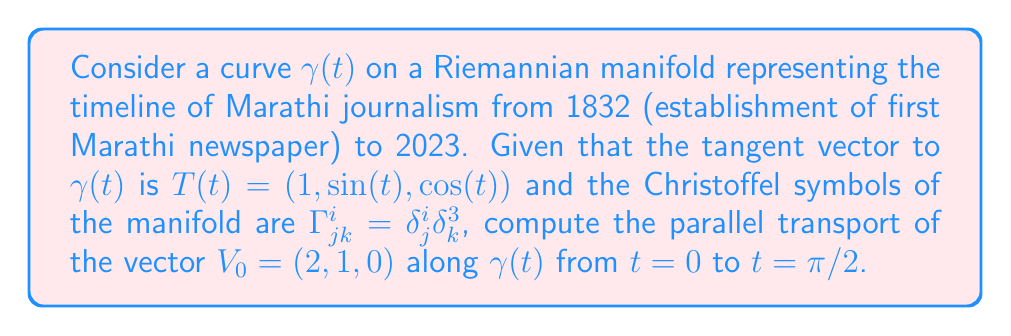Show me your answer to this math problem. To solve this problem, we'll follow these steps:

1) The parallel transport equation is given by:

   $$\frac{dV^i}{dt} + \Gamma^i_{jk} \frac{dx^j}{dt} V^k = 0$$

2) Given $\Gamma^i_{jk} = \delta^i_j \delta_k^3$, we can simplify this equation:

   $$\frac{dV^i}{dt} + \delta^i_j \delta_k^3 T^j V^k = 0$$

3) This simplifies to:

   $$\frac{dV^i}{dt} + T^i V^3 = 0$$

4) We can write this as a system of equations:

   $$\frac{dV^1}{dt} + V^3 = 0$$
   $$\frac{dV^2}{dt} + \sin(t)V^3 = 0$$
   $$\frac{dV^3}{dt} + \cos(t)V^3 = 0$$

5) From the last equation:

   $$\frac{dV^3}{dt} = -\cos(t)V^3$$

   This has the solution $V^3(t) = C e^{\sin(t)}$, where $C$ is a constant.

6) Given $V_0 = (2, 1, 0)$, we have $V^3(0) = 0$, so $C = 0$ and $V^3(t) = 0$ for all $t$.

7) This simplifies our other two equations to:

   $$\frac{dV^1}{dt} = 0$$
   $$\frac{dV^2}{dt} = 0$$

8) These have the solutions $V^1(t) = 2$ and $V^2(t) = 1$ for all $t$.

9) Therefore, the parallel transport of $V_0$ along $\gamma(t)$ is constant:

   $$V(t) = (2, 1, 0)$$

10) At $t = \pi/2$, we have $V(\pi/2) = (2, 1, 0)$.
Answer: $(2, 1, 0)$ 